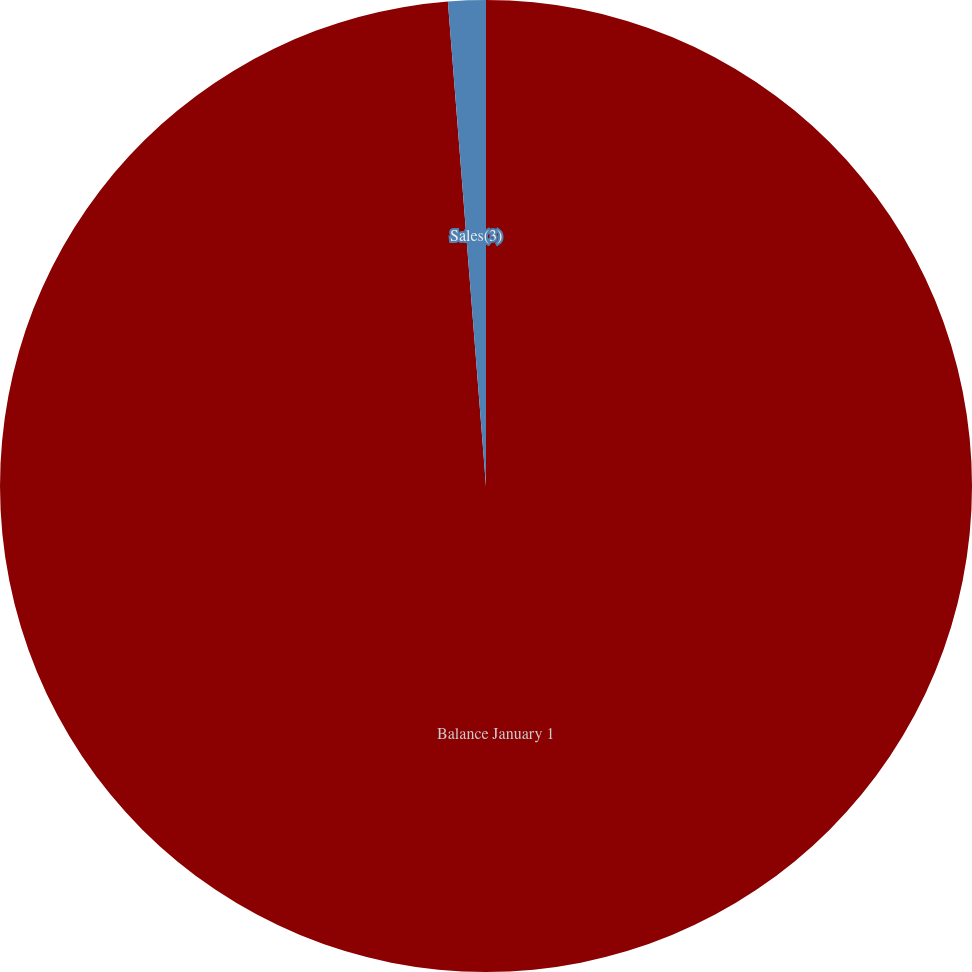<chart> <loc_0><loc_0><loc_500><loc_500><pie_chart><fcel>Balance January 1<fcel>Sales(3)<nl><fcel>98.75%<fcel>1.25%<nl></chart> 